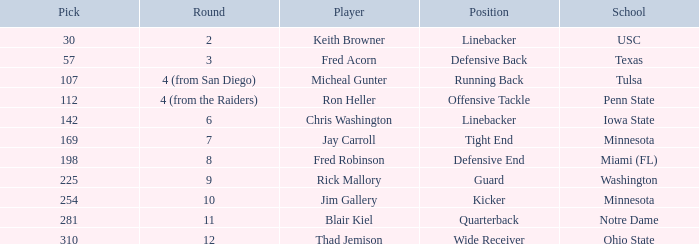What is penn state's draft pick number? 112.0. 